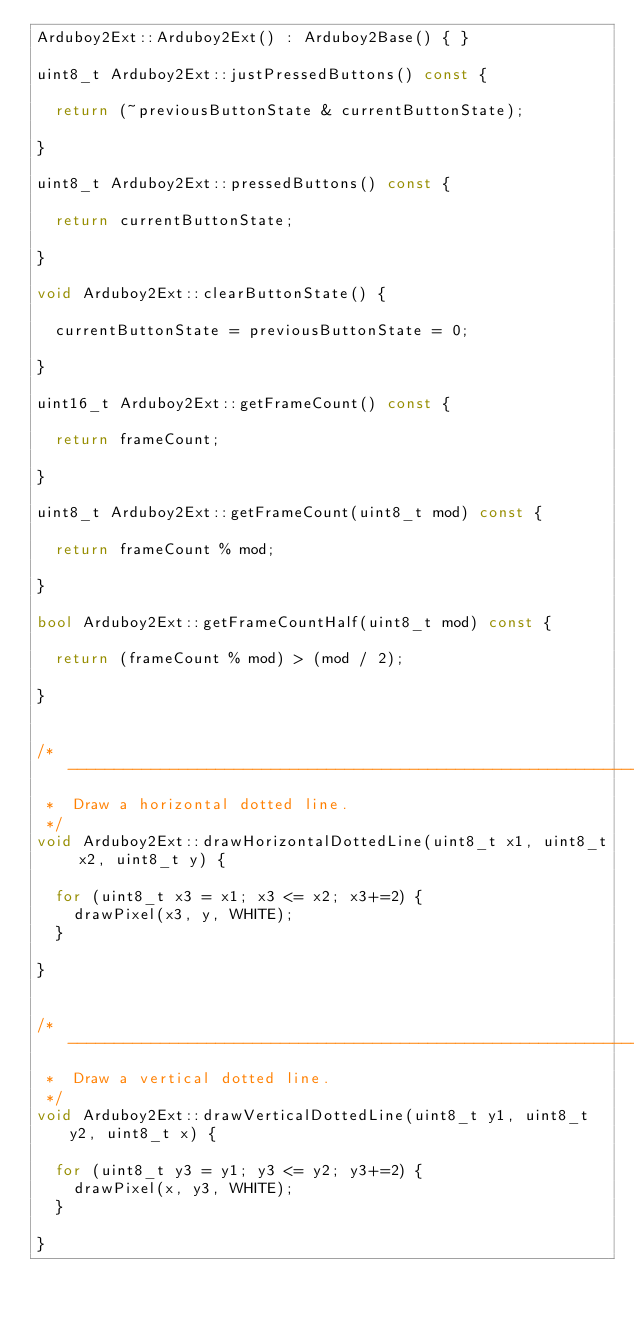Convert code to text. <code><loc_0><loc_0><loc_500><loc_500><_C++_>Arduboy2Ext::Arduboy2Ext() : Arduboy2Base() { }

uint8_t Arduboy2Ext::justPressedButtons() const {

  return (~previousButtonState & currentButtonState);

}

uint8_t Arduboy2Ext::pressedButtons() const {

  return currentButtonState;

}

void Arduboy2Ext::clearButtonState() {

  currentButtonState = previousButtonState = 0;

}

uint16_t Arduboy2Ext::getFrameCount() const {

  return frameCount;

}

uint8_t Arduboy2Ext::getFrameCount(uint8_t mod) const {

  return frameCount % mod;

}

bool Arduboy2Ext::getFrameCountHalf(uint8_t mod) const {

  return (frameCount % mod) > (mod / 2);

}


/* ----------------------------------------------------------------------------
 *  Draw a horizontal dotted line. 
 */
void Arduboy2Ext::drawHorizontalDottedLine(uint8_t x1, uint8_t x2, uint8_t y) {

  for (uint8_t x3 = x1; x3 <= x2; x3+=2) {
    drawPixel(x3, y, WHITE);
  }
  
}


/* ----------------------------------------------------------------------------
 *  Draw a vertical dotted line. 
 */
void Arduboy2Ext::drawVerticalDottedLine(uint8_t y1, uint8_t y2, uint8_t x) {

  for (uint8_t y3 = y1; y3 <= y2; y3+=2) {
    drawPixel(x, y3, WHITE);
  }
  
}</code> 